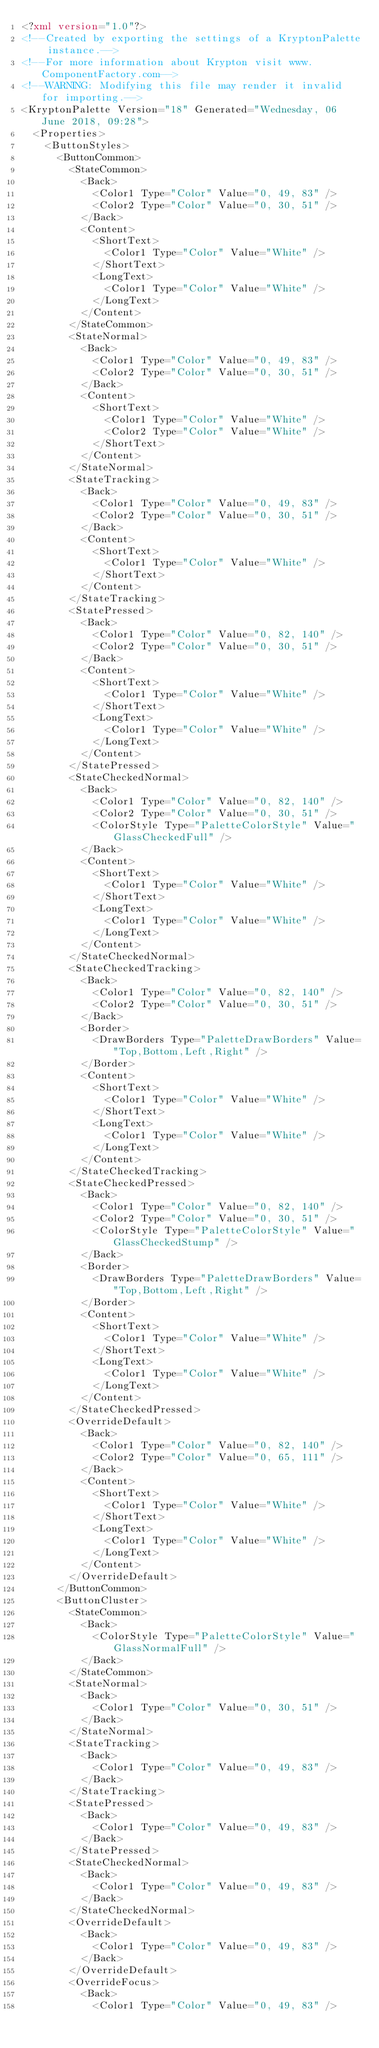<code> <loc_0><loc_0><loc_500><loc_500><_XML_><?xml version="1.0"?>
<!--Created by exporting the settings of a KryptonPalette instance.-->
<!--For more information about Krypton visit www.ComponentFactory.com-->
<!--WARNING: Modifying this file may render it invalid for importing.-->
<KryptonPalette Version="18" Generated="Wednesday, 06 June 2018, 09:28">
  <Properties>
    <ButtonStyles>
      <ButtonCommon>
        <StateCommon>
          <Back>
            <Color1 Type="Color" Value="0, 49, 83" />
            <Color2 Type="Color" Value="0, 30, 51" />
          </Back>
          <Content>
            <ShortText>
              <Color1 Type="Color" Value="White" />
            </ShortText>
            <LongText>
              <Color1 Type="Color" Value="White" />
            </LongText>
          </Content>
        </StateCommon>
        <StateNormal>
          <Back>
            <Color1 Type="Color" Value="0, 49, 83" />
            <Color2 Type="Color" Value="0, 30, 51" />
          </Back>
          <Content>
            <ShortText>
              <Color1 Type="Color" Value="White" />
              <Color2 Type="Color" Value="White" />
            </ShortText>
          </Content>
        </StateNormal>
        <StateTracking>
          <Back>
            <Color1 Type="Color" Value="0, 49, 83" />
            <Color2 Type="Color" Value="0, 30, 51" />
          </Back>
          <Content>
            <ShortText>
              <Color1 Type="Color" Value="White" />
            </ShortText>
          </Content>
        </StateTracking>
        <StatePressed>
          <Back>
            <Color1 Type="Color" Value="0, 82, 140" />
            <Color2 Type="Color" Value="0, 30, 51" />
          </Back>
          <Content>
            <ShortText>
              <Color1 Type="Color" Value="White" />
            </ShortText>
            <LongText>
              <Color1 Type="Color" Value="White" />
            </LongText>
          </Content>
        </StatePressed>
        <StateCheckedNormal>
          <Back>
            <Color1 Type="Color" Value="0, 82, 140" />
            <Color2 Type="Color" Value="0, 30, 51" />
            <ColorStyle Type="PaletteColorStyle" Value="GlassCheckedFull" />
          </Back>
          <Content>
            <ShortText>
              <Color1 Type="Color" Value="White" />
            </ShortText>
            <LongText>
              <Color1 Type="Color" Value="White" />
            </LongText>
          </Content>
        </StateCheckedNormal>
        <StateCheckedTracking>
          <Back>
            <Color1 Type="Color" Value="0, 82, 140" />
            <Color2 Type="Color" Value="0, 30, 51" />
          </Back>
          <Border>
            <DrawBorders Type="PaletteDrawBorders" Value="Top,Bottom,Left,Right" />
          </Border>
          <Content>
            <ShortText>
              <Color1 Type="Color" Value="White" />
            </ShortText>
            <LongText>
              <Color1 Type="Color" Value="White" />
            </LongText>
          </Content>
        </StateCheckedTracking>
        <StateCheckedPressed>
          <Back>
            <Color1 Type="Color" Value="0, 82, 140" />
            <Color2 Type="Color" Value="0, 30, 51" />
            <ColorStyle Type="PaletteColorStyle" Value="GlassCheckedStump" />
          </Back>
          <Border>
            <DrawBorders Type="PaletteDrawBorders" Value="Top,Bottom,Left,Right" />
          </Border>
          <Content>
            <ShortText>
              <Color1 Type="Color" Value="White" />
            </ShortText>
            <LongText>
              <Color1 Type="Color" Value="White" />
            </LongText>
          </Content>
        </StateCheckedPressed>
        <OverrideDefault>
          <Back>
            <Color1 Type="Color" Value="0, 82, 140" />
            <Color2 Type="Color" Value="0, 65, 111" />
          </Back>
          <Content>
            <ShortText>
              <Color1 Type="Color" Value="White" />
            </ShortText>
            <LongText>
              <Color1 Type="Color" Value="White" />
            </LongText>
          </Content>
        </OverrideDefault>
      </ButtonCommon>
      <ButtonCluster>
        <StateCommon>
          <Back>
            <ColorStyle Type="PaletteColorStyle" Value="GlassNormalFull" />
          </Back>
        </StateCommon>
        <StateNormal>
          <Back>
            <Color1 Type="Color" Value="0, 30, 51" />
          </Back>
        </StateNormal>
        <StateTracking>
          <Back>
            <Color1 Type="Color" Value="0, 49, 83" />
          </Back>
        </StateTracking>
        <StatePressed>
          <Back>
            <Color1 Type="Color" Value="0, 49, 83" />
          </Back>
        </StatePressed>
        <StateCheckedNormal>
          <Back>
            <Color1 Type="Color" Value="0, 49, 83" />
          </Back>
        </StateCheckedNormal>
        <OverrideDefault>
          <Back>
            <Color1 Type="Color" Value="0, 49, 83" />
          </Back>
        </OverrideDefault>
        <OverrideFocus>
          <Back>
            <Color1 Type="Color" Value="0, 49, 83" /></code> 